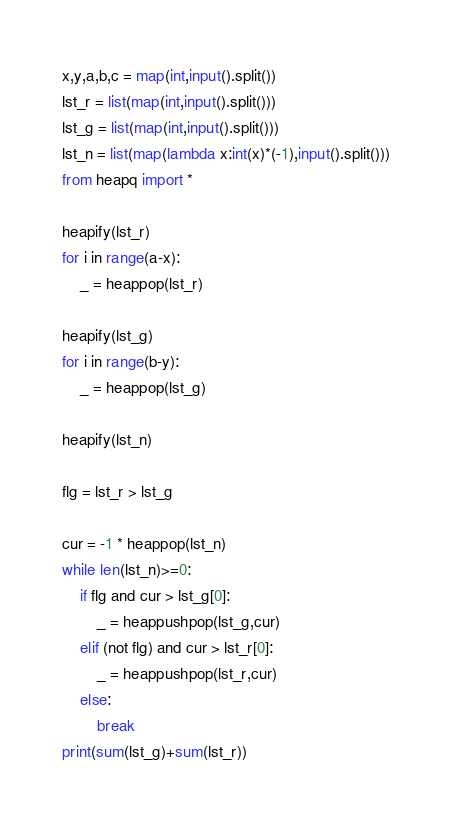<code> <loc_0><loc_0><loc_500><loc_500><_Python_>x,y,a,b,c = map(int,input().split())
lst_r = list(map(int,input().split()))
lst_g = list(map(int,input().split()))
lst_n = list(map(lambda x:int(x)*(-1),input().split()))
from heapq import *

heapify(lst_r)
for i in range(a-x):
    _ = heappop(lst_r)

heapify(lst_g)
for i in range(b-y):
    _ = heappop(lst_g)
    
heapify(lst_n)

flg = lst_r > lst_g

cur = -1 * heappop(lst_n)
while len(lst_n)>=0:
    if flg and cur > lst_g[0]:
        _ = heappushpop(lst_g,cur)
    elif (not flg) and cur > lst_r[0]:
        _ = heappushpop(lst_r,cur)
    else:
        break
print(sum(lst_g)+sum(lst_r))</code> 